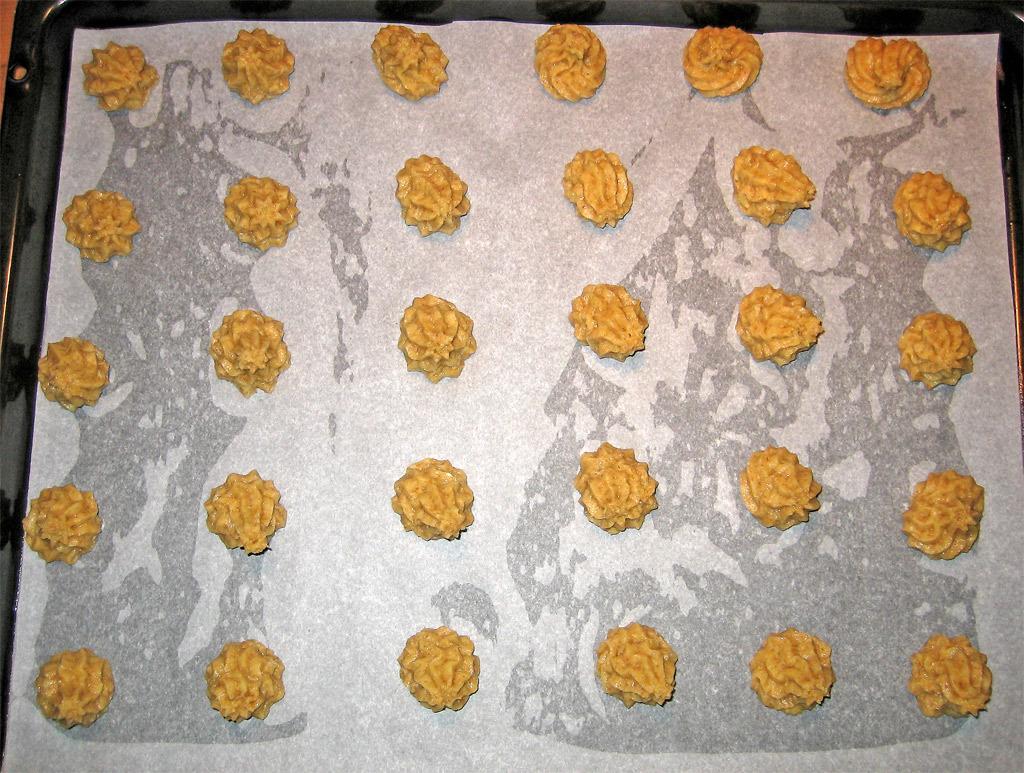Could you give a brief overview of what you see in this image? In this image I see the white paper on which there are many brown color things on it and this white paper is on the black color surface. 